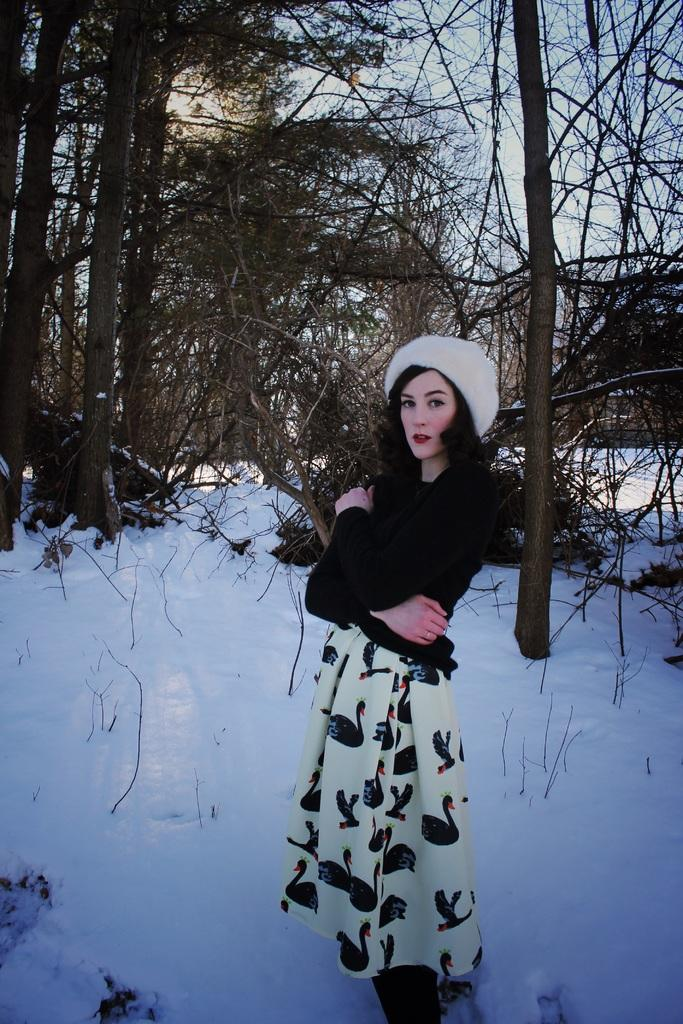What is the main subject of the image? There is a person standing in the image. Can you describe the person's attire? The person is wearing a black and white dress and a white color cap. What can be seen in the background of the image? There are dry trees and snow visible in the background. How would you describe the sky in the image? The sky is blue and white in color. What type of beef is being served on the sofa in the image? There is no beef or sofa present in the image; it features a person standing in a snowy environment with dry trees in the background. 